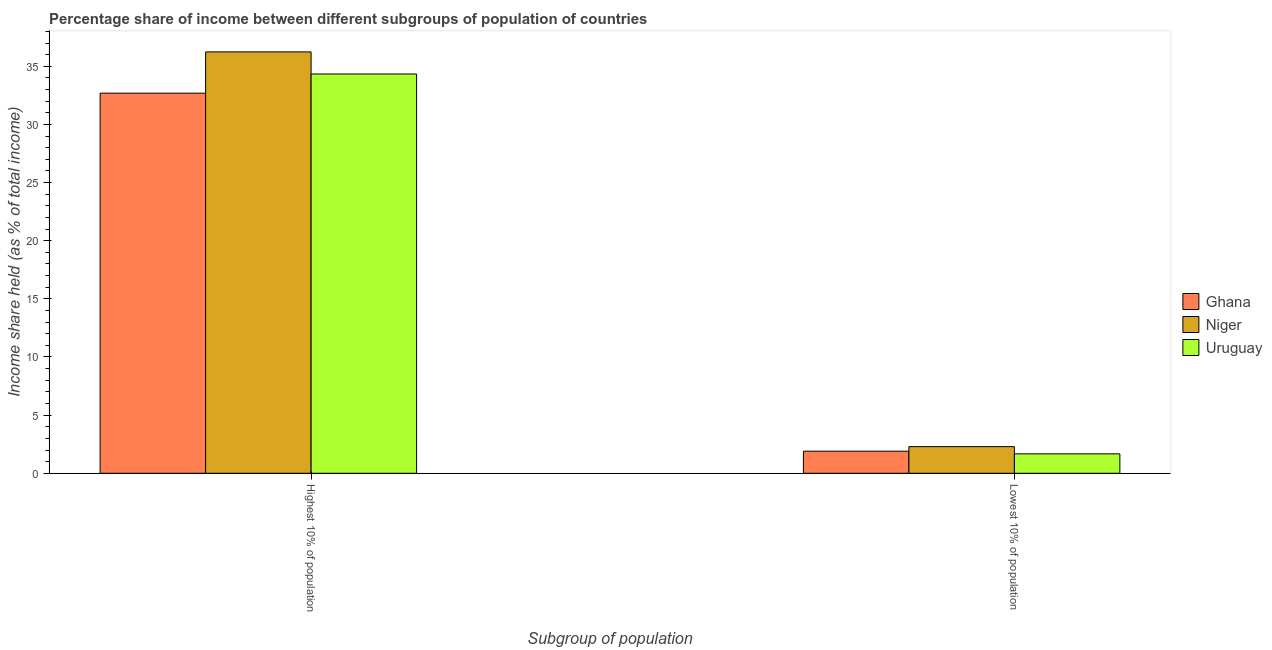How many different coloured bars are there?
Make the answer very short. 3. What is the label of the 2nd group of bars from the left?
Offer a very short reply. Lowest 10% of population. What is the income share held by lowest 10% of the population in Ghana?
Provide a short and direct response. 1.9. Across all countries, what is the maximum income share held by lowest 10% of the population?
Your answer should be compact. 2.29. Across all countries, what is the minimum income share held by highest 10% of the population?
Your response must be concise. 32.69. In which country was the income share held by lowest 10% of the population maximum?
Provide a succinct answer. Niger. In which country was the income share held by lowest 10% of the population minimum?
Make the answer very short. Uruguay. What is the total income share held by highest 10% of the population in the graph?
Offer a terse response. 103.27. What is the difference between the income share held by lowest 10% of the population in Niger and that in Uruguay?
Your response must be concise. 0.62. What is the difference between the income share held by highest 10% of the population in Uruguay and the income share held by lowest 10% of the population in Niger?
Ensure brevity in your answer.  32.05. What is the average income share held by highest 10% of the population per country?
Offer a very short reply. 34.42. What is the difference between the income share held by highest 10% of the population and income share held by lowest 10% of the population in Niger?
Offer a very short reply. 33.95. In how many countries, is the income share held by lowest 10% of the population greater than 14 %?
Keep it short and to the point. 0. What is the ratio of the income share held by lowest 10% of the population in Ghana to that in Uruguay?
Give a very brief answer. 1.14. Is the income share held by highest 10% of the population in Ghana less than that in Niger?
Your response must be concise. Yes. In how many countries, is the income share held by highest 10% of the population greater than the average income share held by highest 10% of the population taken over all countries?
Make the answer very short. 1. What does the 2nd bar from the left in Lowest 10% of population represents?
Offer a terse response. Niger. What does the 1st bar from the right in Highest 10% of population represents?
Make the answer very short. Uruguay. Are the values on the major ticks of Y-axis written in scientific E-notation?
Give a very brief answer. No. Does the graph contain grids?
Offer a terse response. No. Where does the legend appear in the graph?
Ensure brevity in your answer.  Center right. How many legend labels are there?
Your answer should be very brief. 3. How are the legend labels stacked?
Give a very brief answer. Vertical. What is the title of the graph?
Give a very brief answer. Percentage share of income between different subgroups of population of countries. What is the label or title of the X-axis?
Your answer should be very brief. Subgroup of population. What is the label or title of the Y-axis?
Keep it short and to the point. Income share held (as % of total income). What is the Income share held (as % of total income) of Ghana in Highest 10% of population?
Your response must be concise. 32.69. What is the Income share held (as % of total income) in Niger in Highest 10% of population?
Give a very brief answer. 36.24. What is the Income share held (as % of total income) of Uruguay in Highest 10% of population?
Offer a terse response. 34.34. What is the Income share held (as % of total income) of Niger in Lowest 10% of population?
Keep it short and to the point. 2.29. What is the Income share held (as % of total income) in Uruguay in Lowest 10% of population?
Ensure brevity in your answer.  1.67. Across all Subgroup of population, what is the maximum Income share held (as % of total income) in Ghana?
Your answer should be compact. 32.69. Across all Subgroup of population, what is the maximum Income share held (as % of total income) in Niger?
Your answer should be very brief. 36.24. Across all Subgroup of population, what is the maximum Income share held (as % of total income) of Uruguay?
Offer a very short reply. 34.34. Across all Subgroup of population, what is the minimum Income share held (as % of total income) of Ghana?
Your response must be concise. 1.9. Across all Subgroup of population, what is the minimum Income share held (as % of total income) in Niger?
Offer a very short reply. 2.29. Across all Subgroup of population, what is the minimum Income share held (as % of total income) of Uruguay?
Ensure brevity in your answer.  1.67. What is the total Income share held (as % of total income) of Ghana in the graph?
Make the answer very short. 34.59. What is the total Income share held (as % of total income) in Niger in the graph?
Offer a terse response. 38.53. What is the total Income share held (as % of total income) in Uruguay in the graph?
Keep it short and to the point. 36.01. What is the difference between the Income share held (as % of total income) in Ghana in Highest 10% of population and that in Lowest 10% of population?
Offer a terse response. 30.79. What is the difference between the Income share held (as % of total income) of Niger in Highest 10% of population and that in Lowest 10% of population?
Keep it short and to the point. 33.95. What is the difference between the Income share held (as % of total income) of Uruguay in Highest 10% of population and that in Lowest 10% of population?
Your answer should be compact. 32.67. What is the difference between the Income share held (as % of total income) of Ghana in Highest 10% of population and the Income share held (as % of total income) of Niger in Lowest 10% of population?
Your answer should be very brief. 30.4. What is the difference between the Income share held (as % of total income) of Ghana in Highest 10% of population and the Income share held (as % of total income) of Uruguay in Lowest 10% of population?
Offer a very short reply. 31.02. What is the difference between the Income share held (as % of total income) of Niger in Highest 10% of population and the Income share held (as % of total income) of Uruguay in Lowest 10% of population?
Provide a succinct answer. 34.57. What is the average Income share held (as % of total income) of Ghana per Subgroup of population?
Offer a very short reply. 17.3. What is the average Income share held (as % of total income) of Niger per Subgroup of population?
Your response must be concise. 19.27. What is the average Income share held (as % of total income) in Uruguay per Subgroup of population?
Your answer should be very brief. 18. What is the difference between the Income share held (as % of total income) of Ghana and Income share held (as % of total income) of Niger in Highest 10% of population?
Offer a terse response. -3.55. What is the difference between the Income share held (as % of total income) of Ghana and Income share held (as % of total income) of Uruguay in Highest 10% of population?
Offer a terse response. -1.65. What is the difference between the Income share held (as % of total income) in Niger and Income share held (as % of total income) in Uruguay in Highest 10% of population?
Keep it short and to the point. 1.9. What is the difference between the Income share held (as % of total income) of Ghana and Income share held (as % of total income) of Niger in Lowest 10% of population?
Ensure brevity in your answer.  -0.39. What is the difference between the Income share held (as % of total income) in Ghana and Income share held (as % of total income) in Uruguay in Lowest 10% of population?
Keep it short and to the point. 0.23. What is the difference between the Income share held (as % of total income) in Niger and Income share held (as % of total income) in Uruguay in Lowest 10% of population?
Provide a succinct answer. 0.62. What is the ratio of the Income share held (as % of total income) of Ghana in Highest 10% of population to that in Lowest 10% of population?
Your answer should be very brief. 17.21. What is the ratio of the Income share held (as % of total income) in Niger in Highest 10% of population to that in Lowest 10% of population?
Provide a succinct answer. 15.83. What is the ratio of the Income share held (as % of total income) in Uruguay in Highest 10% of population to that in Lowest 10% of population?
Give a very brief answer. 20.56. What is the difference between the highest and the second highest Income share held (as % of total income) of Ghana?
Your response must be concise. 30.79. What is the difference between the highest and the second highest Income share held (as % of total income) of Niger?
Make the answer very short. 33.95. What is the difference between the highest and the second highest Income share held (as % of total income) in Uruguay?
Provide a short and direct response. 32.67. What is the difference between the highest and the lowest Income share held (as % of total income) of Ghana?
Offer a terse response. 30.79. What is the difference between the highest and the lowest Income share held (as % of total income) of Niger?
Your response must be concise. 33.95. What is the difference between the highest and the lowest Income share held (as % of total income) in Uruguay?
Provide a succinct answer. 32.67. 